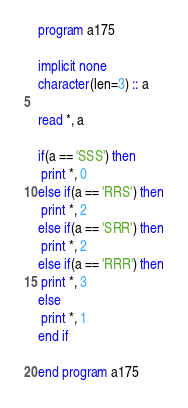<code> <loc_0><loc_0><loc_500><loc_500><_FORTRAN_>program a175

implicit none
character(len=3) :: a

read *, a

if(a == 'SSS') then
 print *, 0
else if(a == 'RRS') then
 print *, 2
else if(a == 'SRR') then
 print *, 2
else if(a == 'RRR') then
 print *, 3
else
 print *, 1
end if

end program a175</code> 